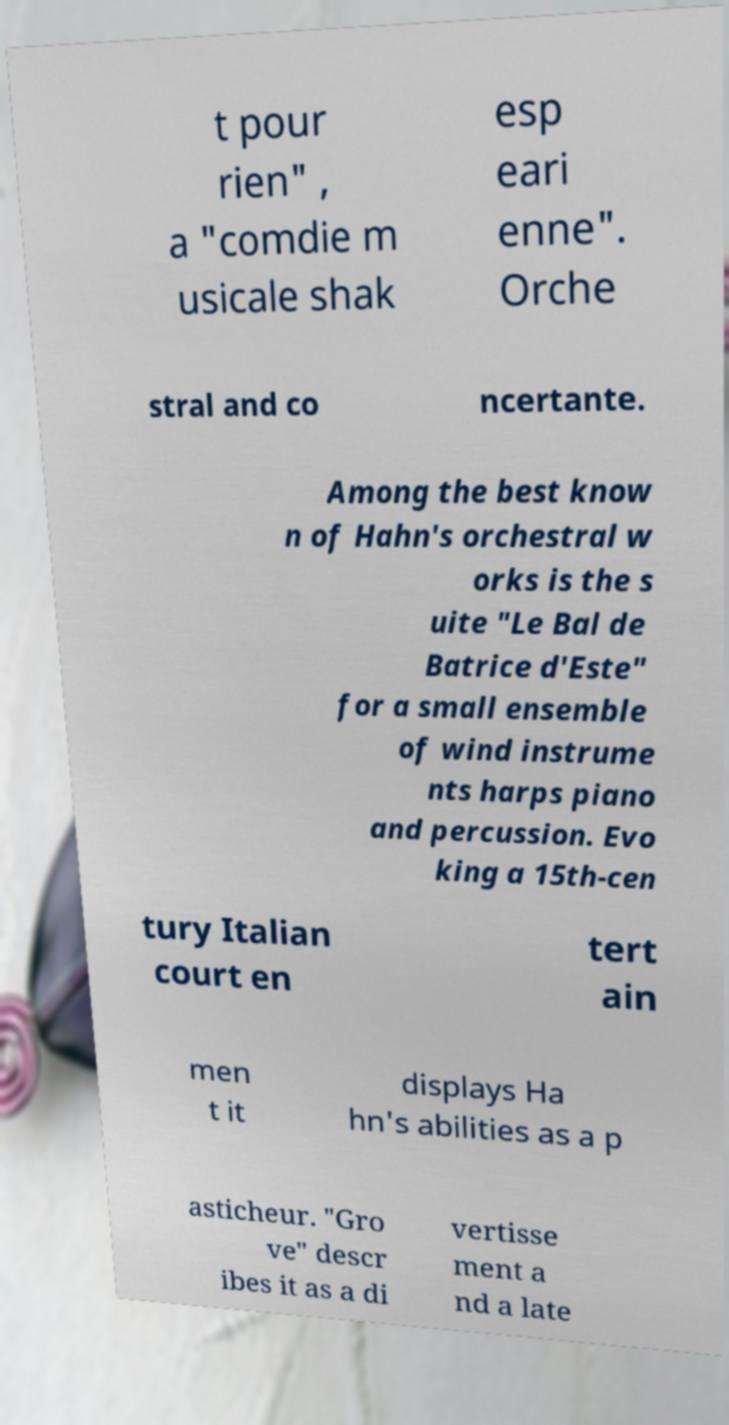There's text embedded in this image that I need extracted. Can you transcribe it verbatim? t pour rien" , a "comdie m usicale shak esp eari enne". Orche stral and co ncertante. Among the best know n of Hahn's orchestral w orks is the s uite "Le Bal de Batrice d'Este" for a small ensemble of wind instrume nts harps piano and percussion. Evo king a 15th-cen tury Italian court en tert ain men t it displays Ha hn's abilities as a p asticheur. "Gro ve" descr ibes it as a di vertisse ment a nd a late 